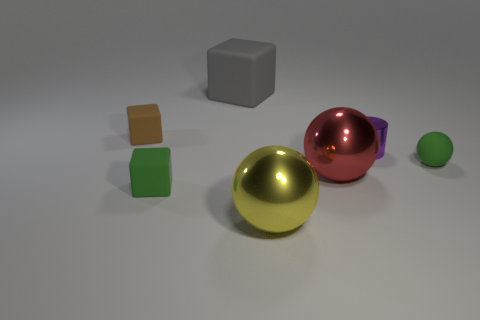Add 2 blue metallic cylinders. How many objects exist? 9 Subtract all tiny rubber cubes. How many cubes are left? 1 Subtract 1 cubes. How many cubes are left? 2 Subtract all blocks. How many objects are left? 4 Add 1 blue metallic cylinders. How many blue metallic cylinders exist? 1 Subtract 0 cyan cubes. How many objects are left? 7 Subtract all yellow cubes. Subtract all brown spheres. How many cubes are left? 3 Subtract all yellow things. Subtract all cyan matte things. How many objects are left? 6 Add 5 gray matte blocks. How many gray matte blocks are left? 6 